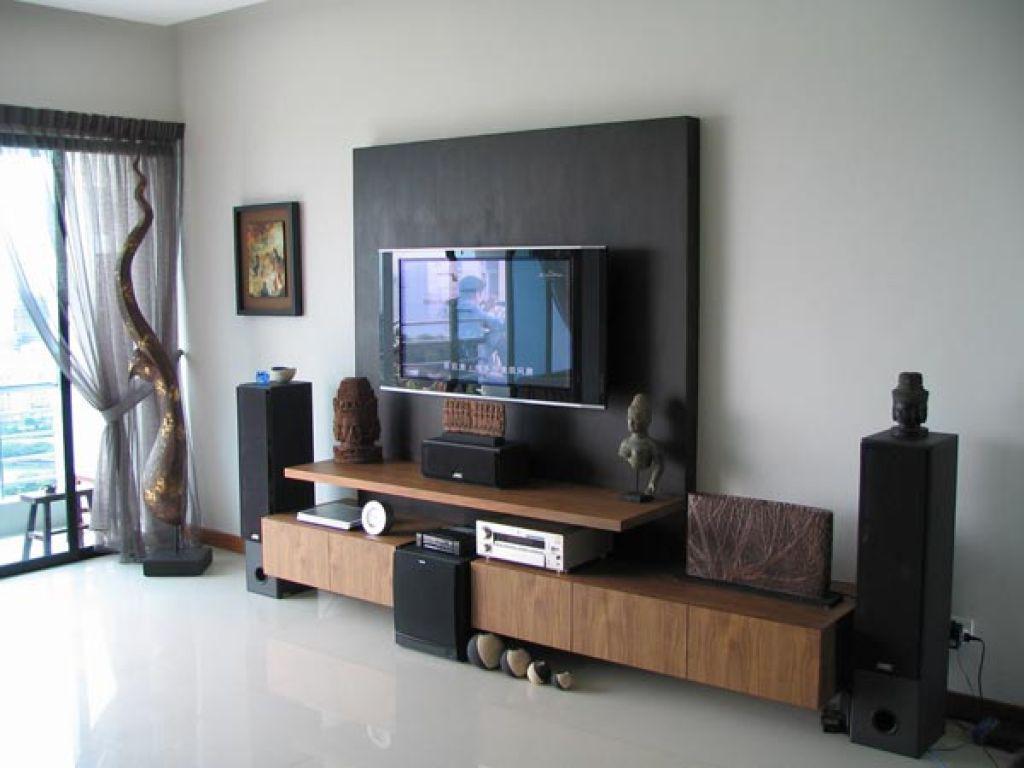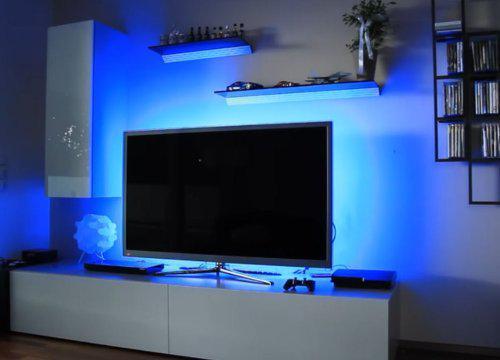The first image is the image on the left, the second image is the image on the right. For the images shown, is this caption "At least one of the televisions is turned off." true? Answer yes or no. Yes. The first image is the image on the left, the second image is the image on the right. Assess this claim about the two images: "There is nothing playing on at least one of the screens.". Correct or not? Answer yes or no. Yes. 